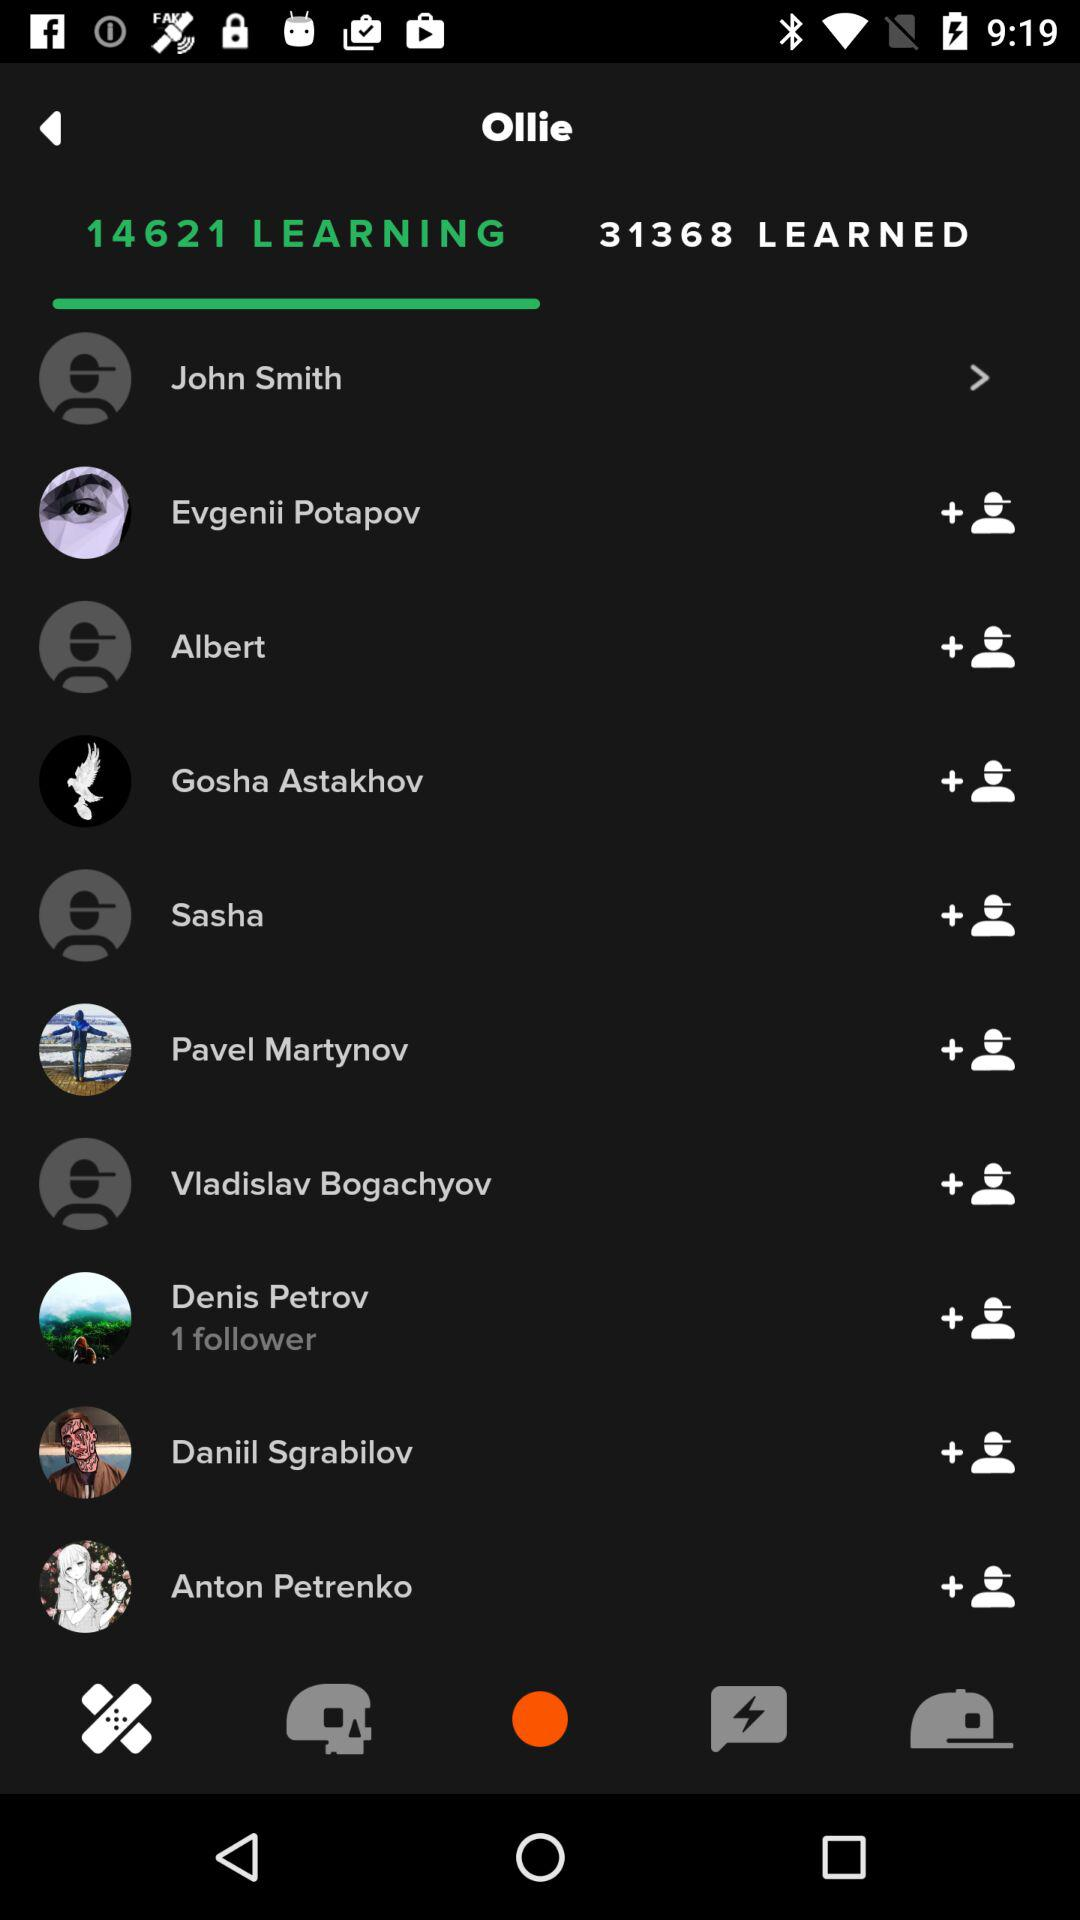What is the current number of people who have learned? The current number of people who have learned is 31368. 